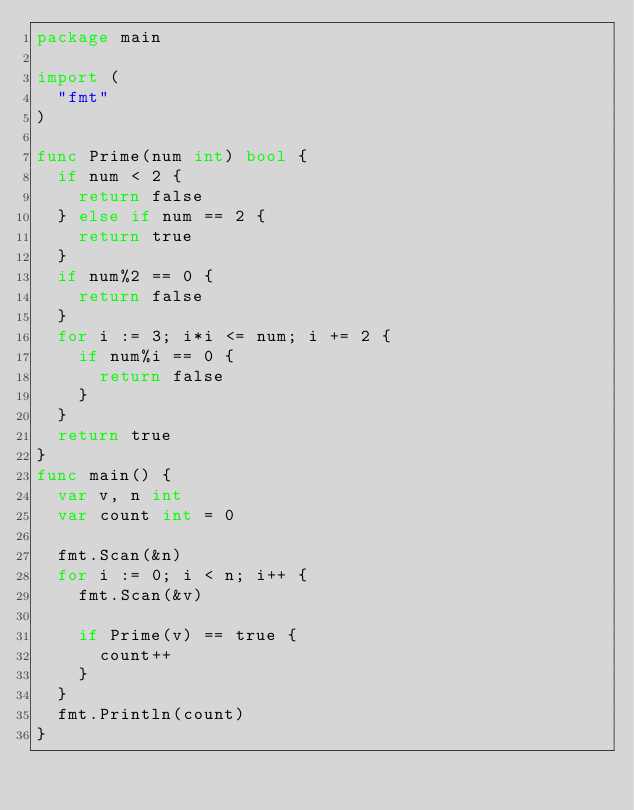<code> <loc_0><loc_0><loc_500><loc_500><_Go_>package main

import (
	"fmt"
)

func Prime(num int) bool {
	if num < 2 {
		return false
	} else if num == 2 {
		return true
	}
	if num%2 == 0 {
		return false
	}
	for i := 3; i*i <= num; i += 2 {
		if num%i == 0 {
			return false
		}
	}
	return true
}
func main() {
	var v, n int
	var count int = 0

	fmt.Scan(&n)
	for i := 0; i < n; i++ {
		fmt.Scan(&v)

		if Prime(v) == true {
			count++
		}
	}
	fmt.Println(count)
}

</code> 